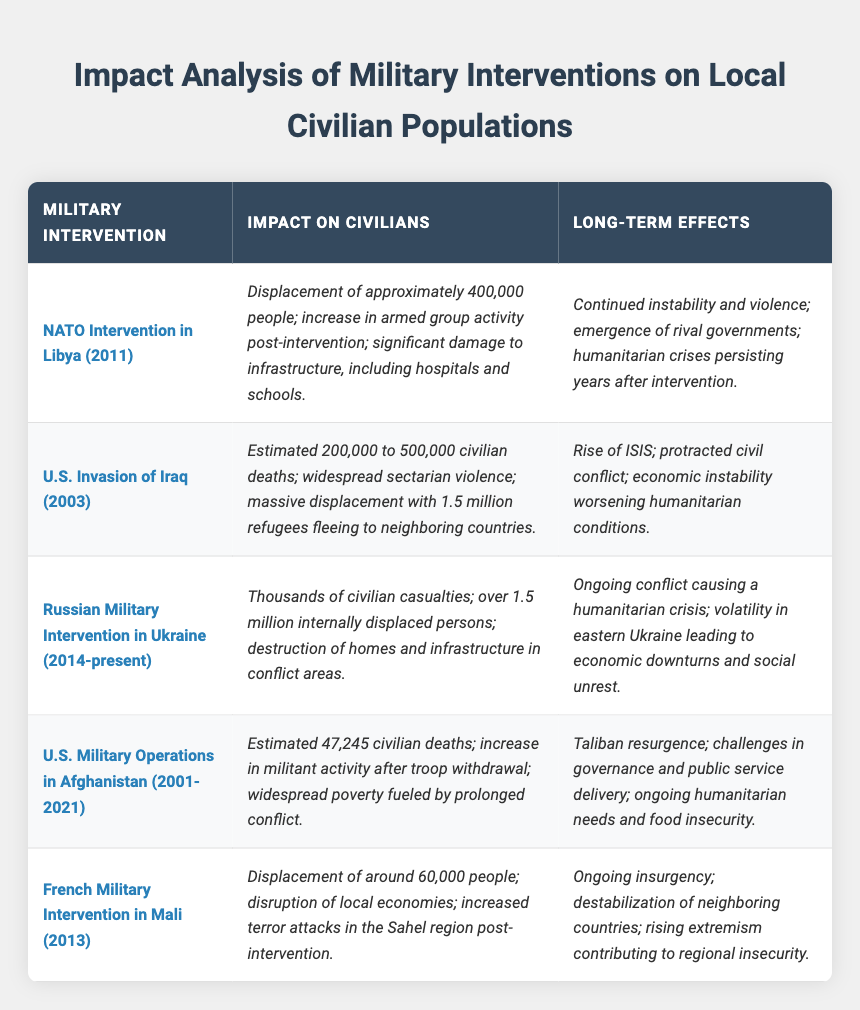What was the civilian displacement caused by the NATO Intervention in Libya? The table states that the NATO Intervention in Libya caused the displacement of approximately 400,000 people.
Answer: 400,000 How many estimated civilian deaths occurred as a result of the U.S. Invasion of Iraq? The U.S. Invasion of Iraq is reported to have resulted in an estimated 200,000 to 500,000 civilian deaths.
Answer: 200,000 to 500,000 Which military intervention resulted in the displacement of around 60,000 people? The table indicates that the French Military Intervention in Mali caused the displacement of around 60,000 people.
Answer: French Military Intervention in Mali What are the long-term effects of the U.S. Military Operations in Afghanistan? The long-term effects include Taliban resurgence, challenges in governance, and ongoing humanitarian needs.
Answer: Multiple effects including Taliban resurgence and ongoing humanitarian needs True or False: The Russian Military Intervention in Ukraine has caused ongoing conflict and social unrest. The table confirms that the Russian Military Intervention has led to ongoing conflict causing a humanitarian crisis and social unrest.
Answer: True What was the difference in estimated civilian deaths between the U.S. Invasion of Iraq and U.S. Military Operations in Afghanistan? The estimated civilian deaths for Iraq range from 200,000 to 500,000, while for Afghanistan it is 47,245. Taking the maximum for Iraq, the difference is 500,000 - 47,245 = 452,755.
Answer: 452,755 Which intervention has caused significant damage to infrastructure, especially hospitals and schools? According to the table, the NATO Intervention in Libya caused significant damage to infrastructure including hospitals and schools.
Answer: NATO Intervention in Libya List the interventions that resulted in ongoing humanitarian crises as a long-term effect. The table shows ongoing humanitarian crises as a long-term effect for NATO Intervention in Libya, U.S. Invasion of Iraq, and U.S. Military Operations in Afghanistan.
Answer: NATO Intervention in Libya, U.S. Invasion of Iraq, U.S. Military Operations in Afghanistan What is the estimated number of internally displaced persons due to the Russian Military Intervention in Ukraine? The data states that there are over 1.5 million internally displaced persons due to the Russian Military Intervention in Ukraine.
Answer: Over 1.5 million How many people were displaced as a result of the French Military Intervention in Mali compared to the NATO Intervention in Libya? The French Military Intervention in Mali displaced around 60,000 people, whereas the NATO Intervention in Libya displaced approximately 400,000 people. The difference is 400,000 - 60,000 = 340,000.
Answer: 340,000 What common long-term effect is noted for both the U.S. Invasion of Iraq and the NATO Intervention in Libya? Both interventions are noted to have resulted in ongoing instability, violence, and humanitarian crises as long-term effects.
Answer: Ongoing instability and humanitarian crises 